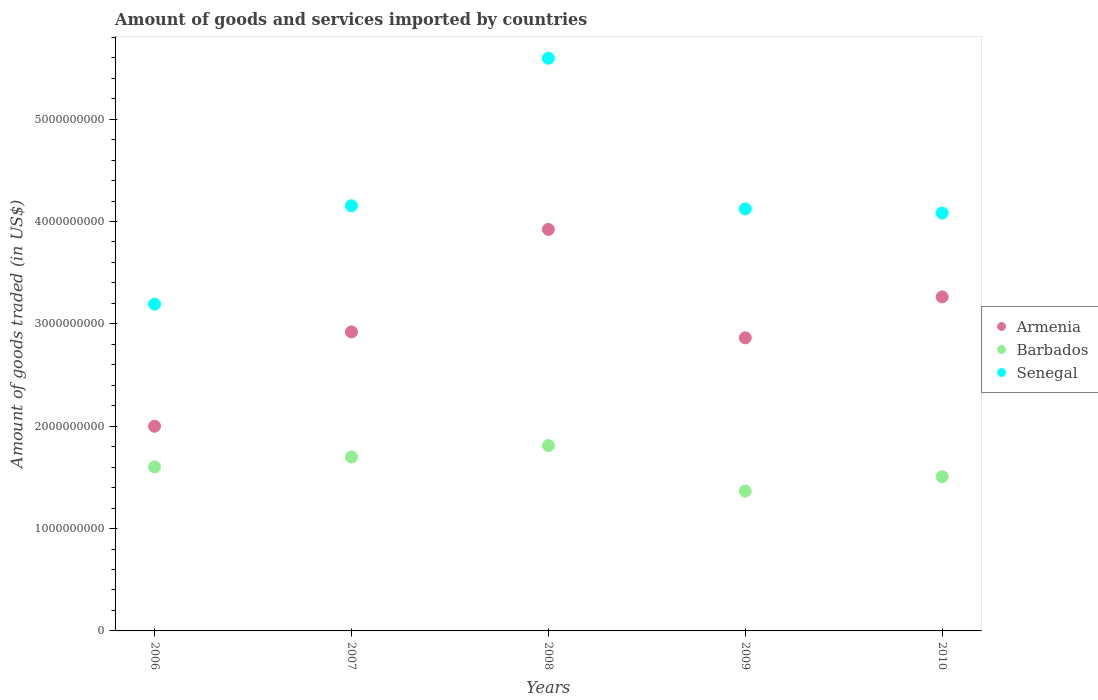How many different coloured dotlines are there?
Make the answer very short. 3. What is the total amount of goods and services imported in Barbados in 2009?
Ensure brevity in your answer.  1.37e+09. Across all years, what is the maximum total amount of goods and services imported in Senegal?
Provide a short and direct response. 5.60e+09. Across all years, what is the minimum total amount of goods and services imported in Barbados?
Provide a short and direct response. 1.37e+09. What is the total total amount of goods and services imported in Senegal in the graph?
Your response must be concise. 2.11e+1. What is the difference between the total amount of goods and services imported in Armenia in 2007 and that in 2010?
Give a very brief answer. -3.42e+08. What is the difference between the total amount of goods and services imported in Armenia in 2006 and the total amount of goods and services imported in Barbados in 2007?
Make the answer very short. 3.00e+08. What is the average total amount of goods and services imported in Senegal per year?
Offer a terse response. 4.23e+09. In the year 2009, what is the difference between the total amount of goods and services imported in Barbados and total amount of goods and services imported in Armenia?
Provide a short and direct response. -1.50e+09. What is the ratio of the total amount of goods and services imported in Senegal in 2007 to that in 2008?
Provide a short and direct response. 0.74. Is the total amount of goods and services imported in Barbados in 2006 less than that in 2010?
Make the answer very short. No. Is the difference between the total amount of goods and services imported in Barbados in 2007 and 2010 greater than the difference between the total amount of goods and services imported in Armenia in 2007 and 2010?
Make the answer very short. Yes. What is the difference between the highest and the second highest total amount of goods and services imported in Barbados?
Make the answer very short. 1.11e+08. What is the difference between the highest and the lowest total amount of goods and services imported in Armenia?
Offer a very short reply. 1.92e+09. Is the sum of the total amount of goods and services imported in Barbados in 2008 and 2010 greater than the maximum total amount of goods and services imported in Senegal across all years?
Offer a very short reply. No. Does the total amount of goods and services imported in Senegal monotonically increase over the years?
Offer a terse response. No. Is the total amount of goods and services imported in Barbados strictly greater than the total amount of goods and services imported in Senegal over the years?
Your answer should be very brief. No. Is the total amount of goods and services imported in Senegal strictly less than the total amount of goods and services imported in Armenia over the years?
Make the answer very short. No. How many years are there in the graph?
Ensure brevity in your answer.  5. Are the values on the major ticks of Y-axis written in scientific E-notation?
Your answer should be compact. No. Where does the legend appear in the graph?
Provide a short and direct response. Center right. How are the legend labels stacked?
Your answer should be compact. Vertical. What is the title of the graph?
Your response must be concise. Amount of goods and services imported by countries. What is the label or title of the X-axis?
Your answer should be compact. Years. What is the label or title of the Y-axis?
Keep it short and to the point. Amount of goods traded (in US$). What is the Amount of goods traded (in US$) in Armenia in 2006?
Your response must be concise. 2.00e+09. What is the Amount of goods traded (in US$) in Barbados in 2006?
Make the answer very short. 1.60e+09. What is the Amount of goods traded (in US$) in Senegal in 2006?
Ensure brevity in your answer.  3.19e+09. What is the Amount of goods traded (in US$) of Armenia in 2007?
Offer a terse response. 2.92e+09. What is the Amount of goods traded (in US$) in Barbados in 2007?
Make the answer very short. 1.70e+09. What is the Amount of goods traded (in US$) of Senegal in 2007?
Your answer should be compact. 4.15e+09. What is the Amount of goods traded (in US$) of Armenia in 2008?
Provide a succinct answer. 3.92e+09. What is the Amount of goods traded (in US$) of Barbados in 2008?
Keep it short and to the point. 1.81e+09. What is the Amount of goods traded (in US$) in Senegal in 2008?
Your answer should be compact. 5.60e+09. What is the Amount of goods traded (in US$) of Armenia in 2009?
Offer a very short reply. 2.86e+09. What is the Amount of goods traded (in US$) in Barbados in 2009?
Your answer should be compact. 1.37e+09. What is the Amount of goods traded (in US$) in Senegal in 2009?
Offer a very short reply. 4.12e+09. What is the Amount of goods traded (in US$) in Armenia in 2010?
Your answer should be very brief. 3.26e+09. What is the Amount of goods traded (in US$) of Barbados in 2010?
Give a very brief answer. 1.51e+09. What is the Amount of goods traded (in US$) of Senegal in 2010?
Your answer should be very brief. 4.08e+09. Across all years, what is the maximum Amount of goods traded (in US$) in Armenia?
Ensure brevity in your answer.  3.92e+09. Across all years, what is the maximum Amount of goods traded (in US$) in Barbados?
Ensure brevity in your answer.  1.81e+09. Across all years, what is the maximum Amount of goods traded (in US$) in Senegal?
Provide a short and direct response. 5.60e+09. Across all years, what is the minimum Amount of goods traded (in US$) in Armenia?
Offer a terse response. 2.00e+09. Across all years, what is the minimum Amount of goods traded (in US$) of Barbados?
Your answer should be compact. 1.37e+09. Across all years, what is the minimum Amount of goods traded (in US$) of Senegal?
Make the answer very short. 3.19e+09. What is the total Amount of goods traded (in US$) of Armenia in the graph?
Make the answer very short. 1.50e+1. What is the total Amount of goods traded (in US$) in Barbados in the graph?
Make the answer very short. 7.99e+09. What is the total Amount of goods traded (in US$) of Senegal in the graph?
Your response must be concise. 2.11e+1. What is the difference between the Amount of goods traded (in US$) of Armenia in 2006 and that in 2007?
Give a very brief answer. -9.21e+08. What is the difference between the Amount of goods traded (in US$) in Barbados in 2006 and that in 2007?
Provide a succinct answer. -9.72e+07. What is the difference between the Amount of goods traded (in US$) in Senegal in 2006 and that in 2007?
Offer a very short reply. -9.61e+08. What is the difference between the Amount of goods traded (in US$) of Armenia in 2006 and that in 2008?
Offer a terse response. -1.92e+09. What is the difference between the Amount of goods traded (in US$) in Barbados in 2006 and that in 2008?
Offer a terse response. -2.09e+08. What is the difference between the Amount of goods traded (in US$) of Senegal in 2006 and that in 2008?
Keep it short and to the point. -2.40e+09. What is the difference between the Amount of goods traded (in US$) in Armenia in 2006 and that in 2009?
Make the answer very short. -8.64e+08. What is the difference between the Amount of goods traded (in US$) of Barbados in 2006 and that in 2009?
Your answer should be compact. 2.36e+08. What is the difference between the Amount of goods traded (in US$) in Senegal in 2006 and that in 2009?
Ensure brevity in your answer.  -9.30e+08. What is the difference between the Amount of goods traded (in US$) of Armenia in 2006 and that in 2010?
Provide a short and direct response. -1.26e+09. What is the difference between the Amount of goods traded (in US$) of Barbados in 2006 and that in 2010?
Give a very brief answer. 9.58e+07. What is the difference between the Amount of goods traded (in US$) of Senegal in 2006 and that in 2010?
Your answer should be compact. -8.90e+08. What is the difference between the Amount of goods traded (in US$) in Armenia in 2007 and that in 2008?
Keep it short and to the point. -1.00e+09. What is the difference between the Amount of goods traded (in US$) of Barbados in 2007 and that in 2008?
Offer a very short reply. -1.11e+08. What is the difference between the Amount of goods traded (in US$) of Senegal in 2007 and that in 2008?
Give a very brief answer. -1.44e+09. What is the difference between the Amount of goods traded (in US$) of Armenia in 2007 and that in 2009?
Offer a very short reply. 5.75e+07. What is the difference between the Amount of goods traded (in US$) in Barbados in 2007 and that in 2009?
Your answer should be compact. 3.34e+08. What is the difference between the Amount of goods traded (in US$) of Senegal in 2007 and that in 2009?
Provide a short and direct response. 3.09e+07. What is the difference between the Amount of goods traded (in US$) of Armenia in 2007 and that in 2010?
Make the answer very short. -3.42e+08. What is the difference between the Amount of goods traded (in US$) in Barbados in 2007 and that in 2010?
Ensure brevity in your answer.  1.93e+08. What is the difference between the Amount of goods traded (in US$) in Senegal in 2007 and that in 2010?
Make the answer very short. 7.14e+07. What is the difference between the Amount of goods traded (in US$) in Armenia in 2008 and that in 2009?
Offer a terse response. 1.06e+09. What is the difference between the Amount of goods traded (in US$) in Barbados in 2008 and that in 2009?
Make the answer very short. 4.45e+08. What is the difference between the Amount of goods traded (in US$) in Senegal in 2008 and that in 2009?
Make the answer very short. 1.47e+09. What is the difference between the Amount of goods traded (in US$) in Armenia in 2008 and that in 2010?
Offer a very short reply. 6.59e+08. What is the difference between the Amount of goods traded (in US$) of Barbados in 2008 and that in 2010?
Ensure brevity in your answer.  3.04e+08. What is the difference between the Amount of goods traded (in US$) in Senegal in 2008 and that in 2010?
Offer a very short reply. 1.51e+09. What is the difference between the Amount of goods traded (in US$) in Armenia in 2009 and that in 2010?
Ensure brevity in your answer.  -4.00e+08. What is the difference between the Amount of goods traded (in US$) in Barbados in 2009 and that in 2010?
Make the answer very short. -1.41e+08. What is the difference between the Amount of goods traded (in US$) of Senegal in 2009 and that in 2010?
Offer a very short reply. 4.05e+07. What is the difference between the Amount of goods traded (in US$) in Armenia in 2006 and the Amount of goods traded (in US$) in Barbados in 2007?
Your response must be concise. 3.00e+08. What is the difference between the Amount of goods traded (in US$) in Armenia in 2006 and the Amount of goods traded (in US$) in Senegal in 2007?
Provide a succinct answer. -2.15e+09. What is the difference between the Amount of goods traded (in US$) in Barbados in 2006 and the Amount of goods traded (in US$) in Senegal in 2007?
Provide a short and direct response. -2.55e+09. What is the difference between the Amount of goods traded (in US$) of Armenia in 2006 and the Amount of goods traded (in US$) of Barbados in 2008?
Your answer should be compact. 1.89e+08. What is the difference between the Amount of goods traded (in US$) of Armenia in 2006 and the Amount of goods traded (in US$) of Senegal in 2008?
Your answer should be compact. -3.60e+09. What is the difference between the Amount of goods traded (in US$) of Barbados in 2006 and the Amount of goods traded (in US$) of Senegal in 2008?
Offer a terse response. -3.99e+09. What is the difference between the Amount of goods traded (in US$) in Armenia in 2006 and the Amount of goods traded (in US$) in Barbados in 2009?
Make the answer very short. 6.34e+08. What is the difference between the Amount of goods traded (in US$) in Armenia in 2006 and the Amount of goods traded (in US$) in Senegal in 2009?
Offer a very short reply. -2.12e+09. What is the difference between the Amount of goods traded (in US$) in Barbados in 2006 and the Amount of goods traded (in US$) in Senegal in 2009?
Give a very brief answer. -2.52e+09. What is the difference between the Amount of goods traded (in US$) in Armenia in 2006 and the Amount of goods traded (in US$) in Barbados in 2010?
Provide a succinct answer. 4.93e+08. What is the difference between the Amount of goods traded (in US$) of Armenia in 2006 and the Amount of goods traded (in US$) of Senegal in 2010?
Provide a short and direct response. -2.08e+09. What is the difference between the Amount of goods traded (in US$) in Barbados in 2006 and the Amount of goods traded (in US$) in Senegal in 2010?
Offer a very short reply. -2.48e+09. What is the difference between the Amount of goods traded (in US$) in Armenia in 2007 and the Amount of goods traded (in US$) in Barbados in 2008?
Your answer should be very brief. 1.11e+09. What is the difference between the Amount of goods traded (in US$) of Armenia in 2007 and the Amount of goods traded (in US$) of Senegal in 2008?
Provide a short and direct response. -2.67e+09. What is the difference between the Amount of goods traded (in US$) of Barbados in 2007 and the Amount of goods traded (in US$) of Senegal in 2008?
Your response must be concise. -3.90e+09. What is the difference between the Amount of goods traded (in US$) in Armenia in 2007 and the Amount of goods traded (in US$) in Barbados in 2009?
Ensure brevity in your answer.  1.56e+09. What is the difference between the Amount of goods traded (in US$) in Armenia in 2007 and the Amount of goods traded (in US$) in Senegal in 2009?
Make the answer very short. -1.20e+09. What is the difference between the Amount of goods traded (in US$) of Barbados in 2007 and the Amount of goods traded (in US$) of Senegal in 2009?
Provide a short and direct response. -2.42e+09. What is the difference between the Amount of goods traded (in US$) of Armenia in 2007 and the Amount of goods traded (in US$) of Barbados in 2010?
Your response must be concise. 1.41e+09. What is the difference between the Amount of goods traded (in US$) in Armenia in 2007 and the Amount of goods traded (in US$) in Senegal in 2010?
Provide a short and direct response. -1.16e+09. What is the difference between the Amount of goods traded (in US$) of Barbados in 2007 and the Amount of goods traded (in US$) of Senegal in 2010?
Provide a short and direct response. -2.38e+09. What is the difference between the Amount of goods traded (in US$) of Armenia in 2008 and the Amount of goods traded (in US$) of Barbados in 2009?
Your answer should be compact. 2.56e+09. What is the difference between the Amount of goods traded (in US$) in Armenia in 2008 and the Amount of goods traded (in US$) in Senegal in 2009?
Provide a short and direct response. -2.00e+08. What is the difference between the Amount of goods traded (in US$) in Barbados in 2008 and the Amount of goods traded (in US$) in Senegal in 2009?
Your answer should be very brief. -2.31e+09. What is the difference between the Amount of goods traded (in US$) in Armenia in 2008 and the Amount of goods traded (in US$) in Barbados in 2010?
Keep it short and to the point. 2.42e+09. What is the difference between the Amount of goods traded (in US$) of Armenia in 2008 and the Amount of goods traded (in US$) of Senegal in 2010?
Ensure brevity in your answer.  -1.60e+08. What is the difference between the Amount of goods traded (in US$) of Barbados in 2008 and the Amount of goods traded (in US$) of Senegal in 2010?
Offer a terse response. -2.27e+09. What is the difference between the Amount of goods traded (in US$) of Armenia in 2009 and the Amount of goods traded (in US$) of Barbados in 2010?
Give a very brief answer. 1.36e+09. What is the difference between the Amount of goods traded (in US$) of Armenia in 2009 and the Amount of goods traded (in US$) of Senegal in 2010?
Provide a succinct answer. -1.22e+09. What is the difference between the Amount of goods traded (in US$) in Barbados in 2009 and the Amount of goods traded (in US$) in Senegal in 2010?
Offer a very short reply. -2.72e+09. What is the average Amount of goods traded (in US$) in Armenia per year?
Ensure brevity in your answer.  2.99e+09. What is the average Amount of goods traded (in US$) in Barbados per year?
Make the answer very short. 1.60e+09. What is the average Amount of goods traded (in US$) in Senegal per year?
Your response must be concise. 4.23e+09. In the year 2006, what is the difference between the Amount of goods traded (in US$) in Armenia and Amount of goods traded (in US$) in Barbados?
Offer a terse response. 3.97e+08. In the year 2006, what is the difference between the Amount of goods traded (in US$) of Armenia and Amount of goods traded (in US$) of Senegal?
Keep it short and to the point. -1.19e+09. In the year 2006, what is the difference between the Amount of goods traded (in US$) of Barbados and Amount of goods traded (in US$) of Senegal?
Your answer should be very brief. -1.59e+09. In the year 2007, what is the difference between the Amount of goods traded (in US$) of Armenia and Amount of goods traded (in US$) of Barbados?
Your answer should be compact. 1.22e+09. In the year 2007, what is the difference between the Amount of goods traded (in US$) of Armenia and Amount of goods traded (in US$) of Senegal?
Make the answer very short. -1.23e+09. In the year 2007, what is the difference between the Amount of goods traded (in US$) in Barbados and Amount of goods traded (in US$) in Senegal?
Provide a short and direct response. -2.45e+09. In the year 2008, what is the difference between the Amount of goods traded (in US$) in Armenia and Amount of goods traded (in US$) in Barbados?
Make the answer very short. 2.11e+09. In the year 2008, what is the difference between the Amount of goods traded (in US$) in Armenia and Amount of goods traded (in US$) in Senegal?
Keep it short and to the point. -1.67e+09. In the year 2008, what is the difference between the Amount of goods traded (in US$) of Barbados and Amount of goods traded (in US$) of Senegal?
Provide a succinct answer. -3.78e+09. In the year 2009, what is the difference between the Amount of goods traded (in US$) of Armenia and Amount of goods traded (in US$) of Barbados?
Ensure brevity in your answer.  1.50e+09. In the year 2009, what is the difference between the Amount of goods traded (in US$) of Armenia and Amount of goods traded (in US$) of Senegal?
Offer a very short reply. -1.26e+09. In the year 2009, what is the difference between the Amount of goods traded (in US$) in Barbados and Amount of goods traded (in US$) in Senegal?
Offer a terse response. -2.76e+09. In the year 2010, what is the difference between the Amount of goods traded (in US$) in Armenia and Amount of goods traded (in US$) in Barbados?
Provide a short and direct response. 1.76e+09. In the year 2010, what is the difference between the Amount of goods traded (in US$) of Armenia and Amount of goods traded (in US$) of Senegal?
Offer a very short reply. -8.19e+08. In the year 2010, what is the difference between the Amount of goods traded (in US$) of Barbados and Amount of goods traded (in US$) of Senegal?
Offer a very short reply. -2.58e+09. What is the ratio of the Amount of goods traded (in US$) of Armenia in 2006 to that in 2007?
Your response must be concise. 0.68. What is the ratio of the Amount of goods traded (in US$) of Barbados in 2006 to that in 2007?
Your answer should be compact. 0.94. What is the ratio of the Amount of goods traded (in US$) of Senegal in 2006 to that in 2007?
Keep it short and to the point. 0.77. What is the ratio of the Amount of goods traded (in US$) in Armenia in 2006 to that in 2008?
Your answer should be very brief. 0.51. What is the ratio of the Amount of goods traded (in US$) of Barbados in 2006 to that in 2008?
Give a very brief answer. 0.88. What is the ratio of the Amount of goods traded (in US$) of Senegal in 2006 to that in 2008?
Give a very brief answer. 0.57. What is the ratio of the Amount of goods traded (in US$) in Armenia in 2006 to that in 2009?
Offer a terse response. 0.7. What is the ratio of the Amount of goods traded (in US$) of Barbados in 2006 to that in 2009?
Your answer should be compact. 1.17. What is the ratio of the Amount of goods traded (in US$) of Senegal in 2006 to that in 2009?
Your response must be concise. 0.77. What is the ratio of the Amount of goods traded (in US$) of Armenia in 2006 to that in 2010?
Your answer should be compact. 0.61. What is the ratio of the Amount of goods traded (in US$) in Barbados in 2006 to that in 2010?
Your response must be concise. 1.06. What is the ratio of the Amount of goods traded (in US$) of Senegal in 2006 to that in 2010?
Provide a short and direct response. 0.78. What is the ratio of the Amount of goods traded (in US$) of Armenia in 2007 to that in 2008?
Give a very brief answer. 0.74. What is the ratio of the Amount of goods traded (in US$) of Barbados in 2007 to that in 2008?
Provide a short and direct response. 0.94. What is the ratio of the Amount of goods traded (in US$) in Senegal in 2007 to that in 2008?
Your response must be concise. 0.74. What is the ratio of the Amount of goods traded (in US$) of Armenia in 2007 to that in 2009?
Make the answer very short. 1.02. What is the ratio of the Amount of goods traded (in US$) of Barbados in 2007 to that in 2009?
Your answer should be compact. 1.24. What is the ratio of the Amount of goods traded (in US$) of Senegal in 2007 to that in 2009?
Offer a very short reply. 1.01. What is the ratio of the Amount of goods traded (in US$) in Armenia in 2007 to that in 2010?
Make the answer very short. 0.9. What is the ratio of the Amount of goods traded (in US$) in Barbados in 2007 to that in 2010?
Your answer should be very brief. 1.13. What is the ratio of the Amount of goods traded (in US$) of Senegal in 2007 to that in 2010?
Your answer should be compact. 1.02. What is the ratio of the Amount of goods traded (in US$) of Armenia in 2008 to that in 2009?
Keep it short and to the point. 1.37. What is the ratio of the Amount of goods traded (in US$) of Barbados in 2008 to that in 2009?
Provide a short and direct response. 1.33. What is the ratio of the Amount of goods traded (in US$) in Senegal in 2008 to that in 2009?
Your response must be concise. 1.36. What is the ratio of the Amount of goods traded (in US$) of Armenia in 2008 to that in 2010?
Offer a very short reply. 1.2. What is the ratio of the Amount of goods traded (in US$) of Barbados in 2008 to that in 2010?
Give a very brief answer. 1.2. What is the ratio of the Amount of goods traded (in US$) in Senegal in 2008 to that in 2010?
Your answer should be very brief. 1.37. What is the ratio of the Amount of goods traded (in US$) in Armenia in 2009 to that in 2010?
Offer a terse response. 0.88. What is the ratio of the Amount of goods traded (in US$) of Barbados in 2009 to that in 2010?
Give a very brief answer. 0.91. What is the ratio of the Amount of goods traded (in US$) of Senegal in 2009 to that in 2010?
Offer a very short reply. 1.01. What is the difference between the highest and the second highest Amount of goods traded (in US$) in Armenia?
Make the answer very short. 6.59e+08. What is the difference between the highest and the second highest Amount of goods traded (in US$) of Barbados?
Offer a terse response. 1.11e+08. What is the difference between the highest and the second highest Amount of goods traded (in US$) of Senegal?
Give a very brief answer. 1.44e+09. What is the difference between the highest and the lowest Amount of goods traded (in US$) of Armenia?
Provide a succinct answer. 1.92e+09. What is the difference between the highest and the lowest Amount of goods traded (in US$) in Barbados?
Make the answer very short. 4.45e+08. What is the difference between the highest and the lowest Amount of goods traded (in US$) of Senegal?
Offer a terse response. 2.40e+09. 